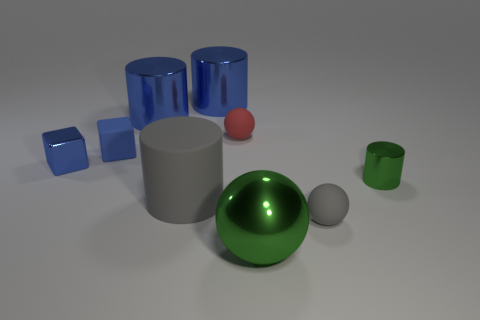Subtract all small balls. How many balls are left? 1 Subtract all green blocks. How many blue cylinders are left? 2 Add 1 blue cylinders. How many objects exist? 10 Subtract all blue cylinders. How many cylinders are left? 2 Subtract 1 cylinders. How many cylinders are left? 3 Subtract all purple cylinders. Subtract all blue balls. How many cylinders are left? 4 Subtract all blocks. How many objects are left? 7 Subtract 0 cyan cylinders. How many objects are left? 9 Subtract all large blue matte blocks. Subtract all blue metallic blocks. How many objects are left? 8 Add 8 blue matte cubes. How many blue matte cubes are left? 9 